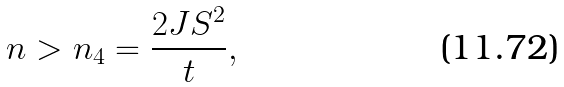Convert formula to latex. <formula><loc_0><loc_0><loc_500><loc_500>n > n _ { 4 } = \frac { 2 J S ^ { 2 } } { t } ,</formula> 